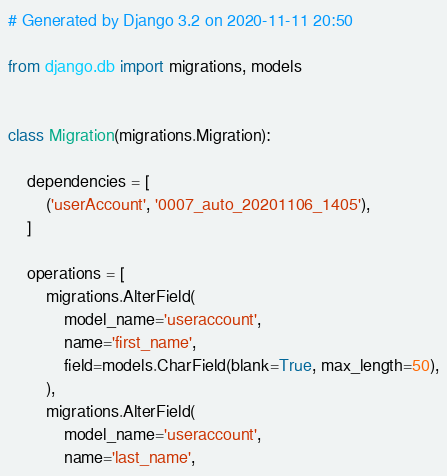Convert code to text. <code><loc_0><loc_0><loc_500><loc_500><_Python_># Generated by Django 3.2 on 2020-11-11 20:50

from django.db import migrations, models


class Migration(migrations.Migration):

    dependencies = [
        ('userAccount', '0007_auto_20201106_1405'),
    ]

    operations = [
        migrations.AlterField(
            model_name='useraccount',
            name='first_name',
            field=models.CharField(blank=True, max_length=50),
        ),
        migrations.AlterField(
            model_name='useraccount',
            name='last_name',</code> 